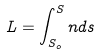<formula> <loc_0><loc_0><loc_500><loc_500>L = \int _ { S _ { o } } ^ { S } n d s</formula> 